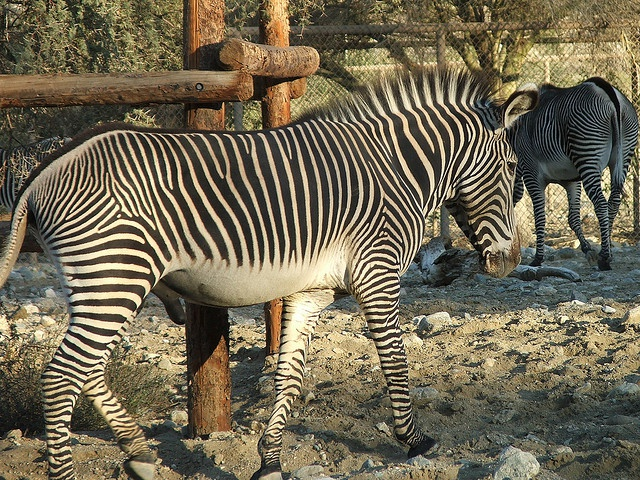Describe the objects in this image and their specific colors. I can see zebra in darkgreen, black, tan, gray, and beige tones and zebra in darkgreen, black, gray, purple, and darkgray tones in this image. 